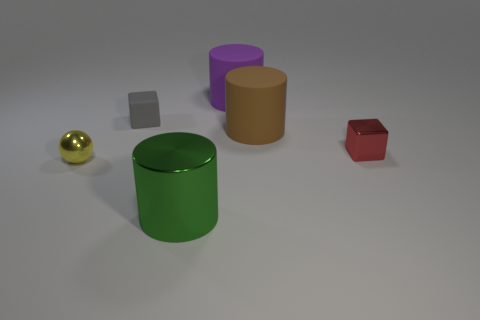Add 4 yellow metallic blocks. How many objects exist? 10 Subtract all blocks. How many objects are left? 4 Subtract all small gray objects. Subtract all small purple shiny objects. How many objects are left? 5 Add 2 blocks. How many blocks are left? 4 Add 5 large blue metal spheres. How many large blue metal spheres exist? 5 Subtract 0 purple spheres. How many objects are left? 6 